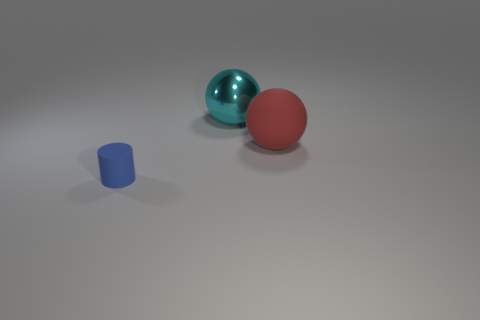Add 3 small purple spheres. How many objects exist? 6 Subtract 0 yellow cylinders. How many objects are left? 3 Subtract all balls. How many objects are left? 1 Subtract all big green balls. Subtract all large red spheres. How many objects are left? 2 Add 3 blue matte cylinders. How many blue matte cylinders are left? 4 Add 3 red matte balls. How many red matte balls exist? 4 